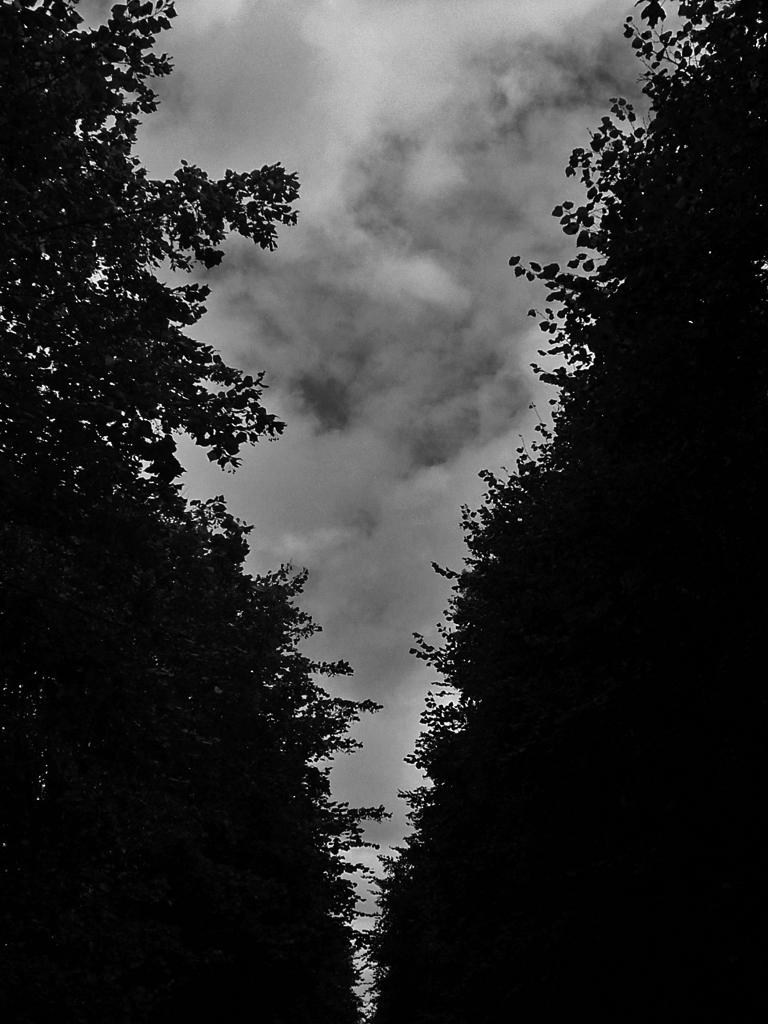What type of vegetation can be seen in the image? There is a group of trees in the image. What is visible in the background of the image? The sky is visible in the background of the image. How would you describe the sky in the image? The sky is cloudy in the image. How many arms are visible on the trees in the image? Trees do not have arms; they have branches. In the image, there are multiple branches visible on the trees. 